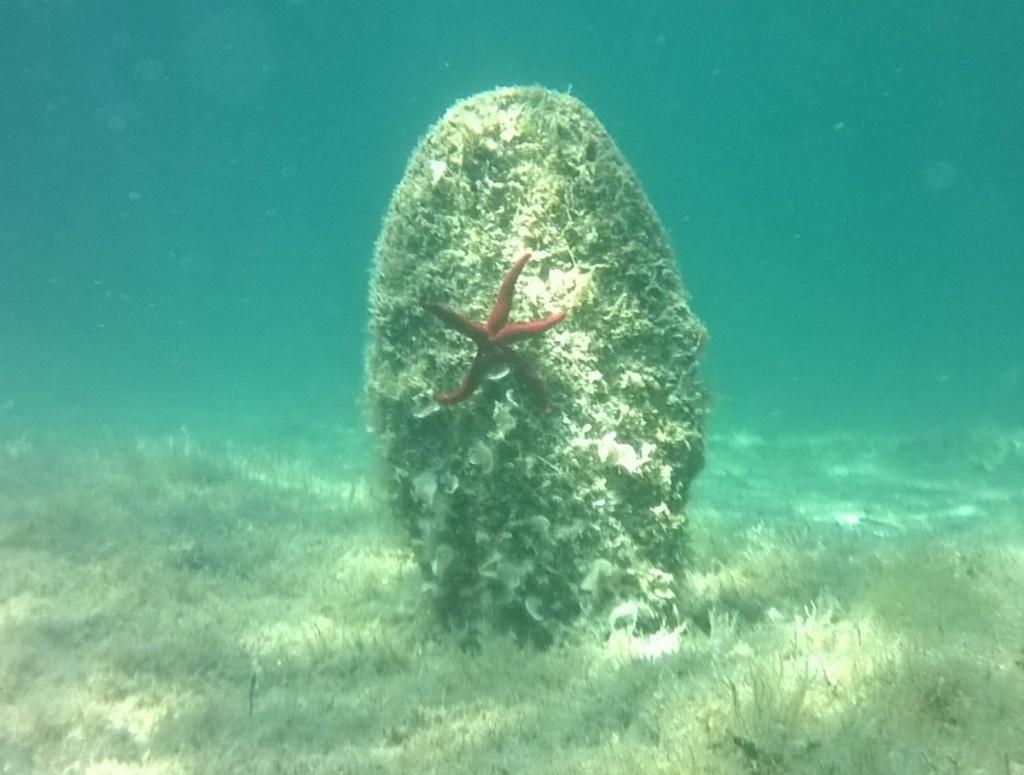Can you describe this image briefly? In this picture we can see a star fish and underwater corals. 